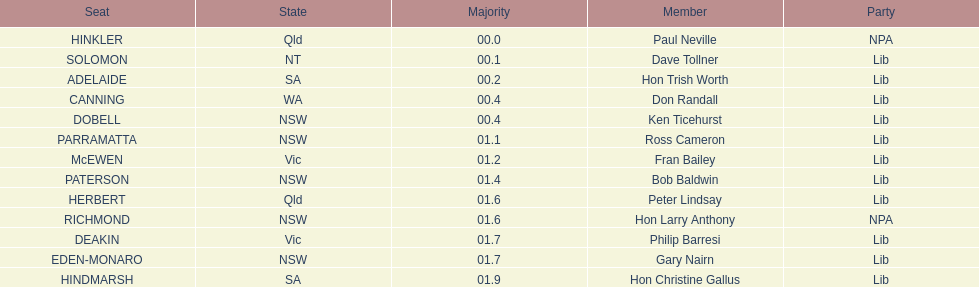Help me parse the entirety of this table. {'header': ['Seat', 'State', 'Majority', 'Member', 'Party'], 'rows': [['HINKLER', 'Qld', '00.0', 'Paul Neville', 'NPA'], ['SOLOMON', 'NT', '00.1', 'Dave Tollner', 'Lib'], ['ADELAIDE', 'SA', '00.2', 'Hon Trish Worth', 'Lib'], ['CANNING', 'WA', '00.4', 'Don Randall', 'Lib'], ['DOBELL', 'NSW', '00.4', 'Ken Ticehurst', 'Lib'], ['PARRAMATTA', 'NSW', '01.1', 'Ross Cameron', 'Lib'], ['McEWEN', 'Vic', '01.2', 'Fran Bailey', 'Lib'], ['PATERSON', 'NSW', '01.4', 'Bob Baldwin', 'Lib'], ['HERBERT', 'Qld', '01.6', 'Peter Lindsay', 'Lib'], ['RICHMOND', 'NSW', '01.6', 'Hon Larry Anthony', 'NPA'], ['DEAKIN', 'Vic', '01.7', 'Philip Barresi', 'Lib'], ['EDEN-MONARO', 'NSW', '01.7', 'Gary Nairn', 'Lib'], ['HINDMARSH', 'SA', '01.9', 'Hon Christine Gallus', 'Lib']]} What is the total of seats? 13. 